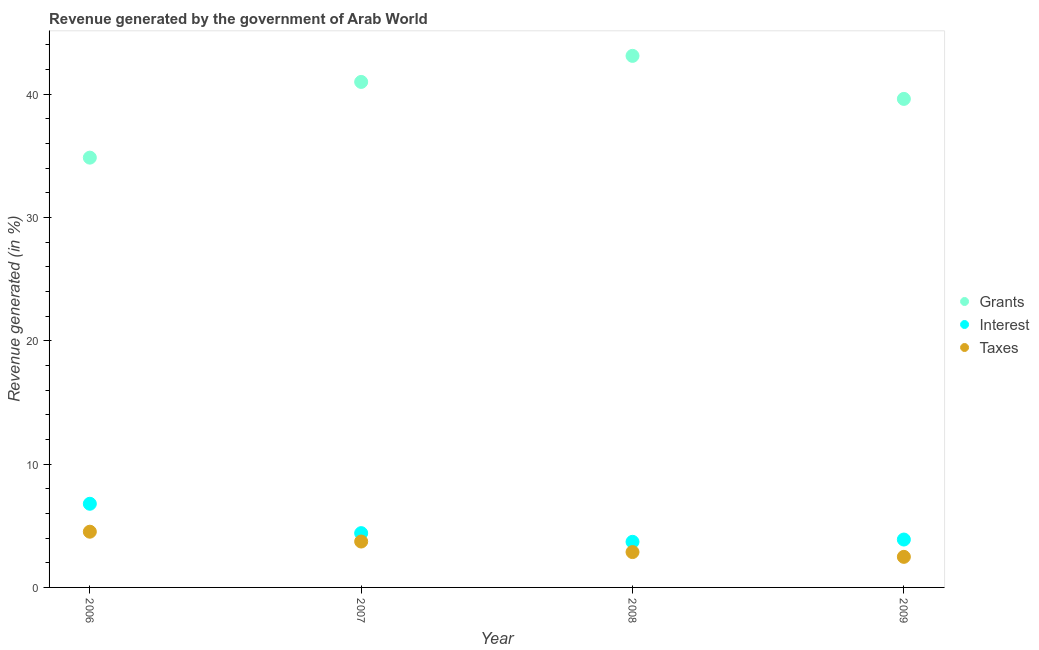What is the percentage of revenue generated by interest in 2008?
Your answer should be very brief. 3.7. Across all years, what is the maximum percentage of revenue generated by interest?
Give a very brief answer. 6.78. Across all years, what is the minimum percentage of revenue generated by grants?
Offer a very short reply. 34.85. In which year was the percentage of revenue generated by interest minimum?
Provide a succinct answer. 2008. What is the total percentage of revenue generated by taxes in the graph?
Give a very brief answer. 13.59. What is the difference between the percentage of revenue generated by grants in 2006 and that in 2007?
Offer a very short reply. -6.14. What is the difference between the percentage of revenue generated by interest in 2006 and the percentage of revenue generated by grants in 2008?
Your answer should be very brief. -36.32. What is the average percentage of revenue generated by grants per year?
Provide a short and direct response. 39.64. In the year 2007, what is the difference between the percentage of revenue generated by interest and percentage of revenue generated by grants?
Give a very brief answer. -36.59. What is the ratio of the percentage of revenue generated by interest in 2008 to that in 2009?
Offer a very short reply. 0.95. Is the percentage of revenue generated by grants in 2006 less than that in 2009?
Offer a terse response. Yes. Is the difference between the percentage of revenue generated by grants in 2008 and 2009 greater than the difference between the percentage of revenue generated by interest in 2008 and 2009?
Offer a very short reply. Yes. What is the difference between the highest and the second highest percentage of revenue generated by grants?
Offer a very short reply. 2.11. What is the difference between the highest and the lowest percentage of revenue generated by grants?
Ensure brevity in your answer.  8.25. Is it the case that in every year, the sum of the percentage of revenue generated by grants and percentage of revenue generated by interest is greater than the percentage of revenue generated by taxes?
Offer a very short reply. Yes. Does the percentage of revenue generated by grants monotonically increase over the years?
Your answer should be compact. No. Is the percentage of revenue generated by interest strictly greater than the percentage of revenue generated by taxes over the years?
Ensure brevity in your answer.  Yes. How many dotlines are there?
Offer a very short reply. 3. How many years are there in the graph?
Your response must be concise. 4. Are the values on the major ticks of Y-axis written in scientific E-notation?
Give a very brief answer. No. Does the graph contain any zero values?
Give a very brief answer. No. Does the graph contain grids?
Give a very brief answer. No. How are the legend labels stacked?
Offer a terse response. Vertical. What is the title of the graph?
Provide a succinct answer. Revenue generated by the government of Arab World. What is the label or title of the X-axis?
Your answer should be very brief. Year. What is the label or title of the Y-axis?
Ensure brevity in your answer.  Revenue generated (in %). What is the Revenue generated (in %) in Grants in 2006?
Keep it short and to the point. 34.85. What is the Revenue generated (in %) in Interest in 2006?
Ensure brevity in your answer.  6.78. What is the Revenue generated (in %) of Taxes in 2006?
Ensure brevity in your answer.  4.52. What is the Revenue generated (in %) in Grants in 2007?
Ensure brevity in your answer.  40.99. What is the Revenue generated (in %) of Interest in 2007?
Provide a short and direct response. 4.4. What is the Revenue generated (in %) in Taxes in 2007?
Offer a very short reply. 3.72. What is the Revenue generated (in %) of Grants in 2008?
Keep it short and to the point. 43.11. What is the Revenue generated (in %) of Interest in 2008?
Offer a very short reply. 3.7. What is the Revenue generated (in %) in Taxes in 2008?
Provide a succinct answer. 2.87. What is the Revenue generated (in %) of Grants in 2009?
Give a very brief answer. 39.62. What is the Revenue generated (in %) in Interest in 2009?
Provide a succinct answer. 3.88. What is the Revenue generated (in %) in Taxes in 2009?
Ensure brevity in your answer.  2.48. Across all years, what is the maximum Revenue generated (in %) of Grants?
Keep it short and to the point. 43.11. Across all years, what is the maximum Revenue generated (in %) of Interest?
Give a very brief answer. 6.78. Across all years, what is the maximum Revenue generated (in %) of Taxes?
Offer a very short reply. 4.52. Across all years, what is the minimum Revenue generated (in %) in Grants?
Your answer should be compact. 34.85. Across all years, what is the minimum Revenue generated (in %) in Interest?
Provide a succinct answer. 3.7. Across all years, what is the minimum Revenue generated (in %) of Taxes?
Provide a short and direct response. 2.48. What is the total Revenue generated (in %) of Grants in the graph?
Ensure brevity in your answer.  158.57. What is the total Revenue generated (in %) of Interest in the graph?
Ensure brevity in your answer.  18.77. What is the total Revenue generated (in %) of Taxes in the graph?
Offer a very short reply. 13.59. What is the difference between the Revenue generated (in %) in Grants in 2006 and that in 2007?
Your answer should be compact. -6.14. What is the difference between the Revenue generated (in %) of Interest in 2006 and that in 2007?
Offer a terse response. 2.38. What is the difference between the Revenue generated (in %) of Taxes in 2006 and that in 2007?
Your answer should be compact. 0.8. What is the difference between the Revenue generated (in %) of Grants in 2006 and that in 2008?
Offer a terse response. -8.25. What is the difference between the Revenue generated (in %) in Interest in 2006 and that in 2008?
Make the answer very short. 3.09. What is the difference between the Revenue generated (in %) of Taxes in 2006 and that in 2008?
Ensure brevity in your answer.  1.65. What is the difference between the Revenue generated (in %) of Grants in 2006 and that in 2009?
Provide a succinct answer. -4.76. What is the difference between the Revenue generated (in %) of Interest in 2006 and that in 2009?
Offer a very short reply. 2.9. What is the difference between the Revenue generated (in %) in Taxes in 2006 and that in 2009?
Your answer should be very brief. 2.04. What is the difference between the Revenue generated (in %) in Grants in 2007 and that in 2008?
Offer a terse response. -2.11. What is the difference between the Revenue generated (in %) of Interest in 2007 and that in 2008?
Your answer should be very brief. 0.71. What is the difference between the Revenue generated (in %) of Taxes in 2007 and that in 2008?
Ensure brevity in your answer.  0.86. What is the difference between the Revenue generated (in %) of Grants in 2007 and that in 2009?
Provide a short and direct response. 1.38. What is the difference between the Revenue generated (in %) of Interest in 2007 and that in 2009?
Give a very brief answer. 0.52. What is the difference between the Revenue generated (in %) of Taxes in 2007 and that in 2009?
Provide a succinct answer. 1.24. What is the difference between the Revenue generated (in %) of Grants in 2008 and that in 2009?
Provide a succinct answer. 3.49. What is the difference between the Revenue generated (in %) of Interest in 2008 and that in 2009?
Provide a succinct answer. -0.19. What is the difference between the Revenue generated (in %) of Taxes in 2008 and that in 2009?
Provide a succinct answer. 0.39. What is the difference between the Revenue generated (in %) of Grants in 2006 and the Revenue generated (in %) of Interest in 2007?
Keep it short and to the point. 30.45. What is the difference between the Revenue generated (in %) of Grants in 2006 and the Revenue generated (in %) of Taxes in 2007?
Make the answer very short. 31.13. What is the difference between the Revenue generated (in %) of Interest in 2006 and the Revenue generated (in %) of Taxes in 2007?
Ensure brevity in your answer.  3.06. What is the difference between the Revenue generated (in %) in Grants in 2006 and the Revenue generated (in %) in Interest in 2008?
Ensure brevity in your answer.  31.16. What is the difference between the Revenue generated (in %) in Grants in 2006 and the Revenue generated (in %) in Taxes in 2008?
Provide a short and direct response. 31.99. What is the difference between the Revenue generated (in %) in Interest in 2006 and the Revenue generated (in %) in Taxes in 2008?
Make the answer very short. 3.92. What is the difference between the Revenue generated (in %) of Grants in 2006 and the Revenue generated (in %) of Interest in 2009?
Give a very brief answer. 30.97. What is the difference between the Revenue generated (in %) of Grants in 2006 and the Revenue generated (in %) of Taxes in 2009?
Give a very brief answer. 32.37. What is the difference between the Revenue generated (in %) in Interest in 2006 and the Revenue generated (in %) in Taxes in 2009?
Provide a succinct answer. 4.3. What is the difference between the Revenue generated (in %) of Grants in 2007 and the Revenue generated (in %) of Interest in 2008?
Ensure brevity in your answer.  37.3. What is the difference between the Revenue generated (in %) of Grants in 2007 and the Revenue generated (in %) of Taxes in 2008?
Your response must be concise. 38.13. What is the difference between the Revenue generated (in %) of Interest in 2007 and the Revenue generated (in %) of Taxes in 2008?
Your response must be concise. 1.54. What is the difference between the Revenue generated (in %) of Grants in 2007 and the Revenue generated (in %) of Interest in 2009?
Ensure brevity in your answer.  37.11. What is the difference between the Revenue generated (in %) in Grants in 2007 and the Revenue generated (in %) in Taxes in 2009?
Make the answer very short. 38.51. What is the difference between the Revenue generated (in %) of Interest in 2007 and the Revenue generated (in %) of Taxes in 2009?
Your answer should be very brief. 1.92. What is the difference between the Revenue generated (in %) of Grants in 2008 and the Revenue generated (in %) of Interest in 2009?
Offer a terse response. 39.22. What is the difference between the Revenue generated (in %) of Grants in 2008 and the Revenue generated (in %) of Taxes in 2009?
Give a very brief answer. 40.63. What is the difference between the Revenue generated (in %) in Interest in 2008 and the Revenue generated (in %) in Taxes in 2009?
Offer a terse response. 1.22. What is the average Revenue generated (in %) of Grants per year?
Keep it short and to the point. 39.64. What is the average Revenue generated (in %) of Interest per year?
Your response must be concise. 4.69. What is the average Revenue generated (in %) of Taxes per year?
Offer a very short reply. 3.4. In the year 2006, what is the difference between the Revenue generated (in %) of Grants and Revenue generated (in %) of Interest?
Offer a terse response. 28.07. In the year 2006, what is the difference between the Revenue generated (in %) in Grants and Revenue generated (in %) in Taxes?
Give a very brief answer. 30.33. In the year 2006, what is the difference between the Revenue generated (in %) of Interest and Revenue generated (in %) of Taxes?
Provide a succinct answer. 2.27. In the year 2007, what is the difference between the Revenue generated (in %) of Grants and Revenue generated (in %) of Interest?
Provide a short and direct response. 36.59. In the year 2007, what is the difference between the Revenue generated (in %) in Grants and Revenue generated (in %) in Taxes?
Your answer should be compact. 37.27. In the year 2007, what is the difference between the Revenue generated (in %) of Interest and Revenue generated (in %) of Taxes?
Your response must be concise. 0.68. In the year 2008, what is the difference between the Revenue generated (in %) of Grants and Revenue generated (in %) of Interest?
Offer a terse response. 39.41. In the year 2008, what is the difference between the Revenue generated (in %) of Grants and Revenue generated (in %) of Taxes?
Your answer should be very brief. 40.24. In the year 2008, what is the difference between the Revenue generated (in %) of Interest and Revenue generated (in %) of Taxes?
Ensure brevity in your answer.  0.83. In the year 2009, what is the difference between the Revenue generated (in %) of Grants and Revenue generated (in %) of Interest?
Offer a very short reply. 35.73. In the year 2009, what is the difference between the Revenue generated (in %) in Grants and Revenue generated (in %) in Taxes?
Offer a terse response. 37.14. In the year 2009, what is the difference between the Revenue generated (in %) of Interest and Revenue generated (in %) of Taxes?
Keep it short and to the point. 1.4. What is the ratio of the Revenue generated (in %) in Grants in 2006 to that in 2007?
Provide a succinct answer. 0.85. What is the ratio of the Revenue generated (in %) in Interest in 2006 to that in 2007?
Offer a terse response. 1.54. What is the ratio of the Revenue generated (in %) of Taxes in 2006 to that in 2007?
Your answer should be very brief. 1.21. What is the ratio of the Revenue generated (in %) of Grants in 2006 to that in 2008?
Keep it short and to the point. 0.81. What is the ratio of the Revenue generated (in %) in Interest in 2006 to that in 2008?
Provide a short and direct response. 1.83. What is the ratio of the Revenue generated (in %) of Taxes in 2006 to that in 2008?
Provide a succinct answer. 1.58. What is the ratio of the Revenue generated (in %) of Grants in 2006 to that in 2009?
Your answer should be very brief. 0.88. What is the ratio of the Revenue generated (in %) in Interest in 2006 to that in 2009?
Give a very brief answer. 1.75. What is the ratio of the Revenue generated (in %) in Taxes in 2006 to that in 2009?
Provide a succinct answer. 1.82. What is the ratio of the Revenue generated (in %) of Grants in 2007 to that in 2008?
Your answer should be very brief. 0.95. What is the ratio of the Revenue generated (in %) of Interest in 2007 to that in 2008?
Ensure brevity in your answer.  1.19. What is the ratio of the Revenue generated (in %) of Taxes in 2007 to that in 2008?
Your answer should be very brief. 1.3. What is the ratio of the Revenue generated (in %) in Grants in 2007 to that in 2009?
Offer a very short reply. 1.03. What is the ratio of the Revenue generated (in %) in Interest in 2007 to that in 2009?
Give a very brief answer. 1.13. What is the ratio of the Revenue generated (in %) in Taxes in 2007 to that in 2009?
Ensure brevity in your answer.  1.5. What is the ratio of the Revenue generated (in %) in Grants in 2008 to that in 2009?
Keep it short and to the point. 1.09. What is the ratio of the Revenue generated (in %) of Interest in 2008 to that in 2009?
Provide a short and direct response. 0.95. What is the ratio of the Revenue generated (in %) of Taxes in 2008 to that in 2009?
Make the answer very short. 1.16. What is the difference between the highest and the second highest Revenue generated (in %) of Grants?
Your answer should be compact. 2.11. What is the difference between the highest and the second highest Revenue generated (in %) of Interest?
Your answer should be very brief. 2.38. What is the difference between the highest and the second highest Revenue generated (in %) in Taxes?
Keep it short and to the point. 0.8. What is the difference between the highest and the lowest Revenue generated (in %) of Grants?
Make the answer very short. 8.25. What is the difference between the highest and the lowest Revenue generated (in %) of Interest?
Keep it short and to the point. 3.09. What is the difference between the highest and the lowest Revenue generated (in %) in Taxes?
Keep it short and to the point. 2.04. 